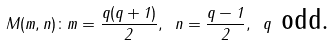Convert formula to latex. <formula><loc_0><loc_0><loc_500><loc_500>M ( m , n ) \colon m = \frac { q ( q + 1 ) } { 2 } , \text { } n = \frac { q - 1 } { 2 } , \text { } q \text { odd.}</formula> 